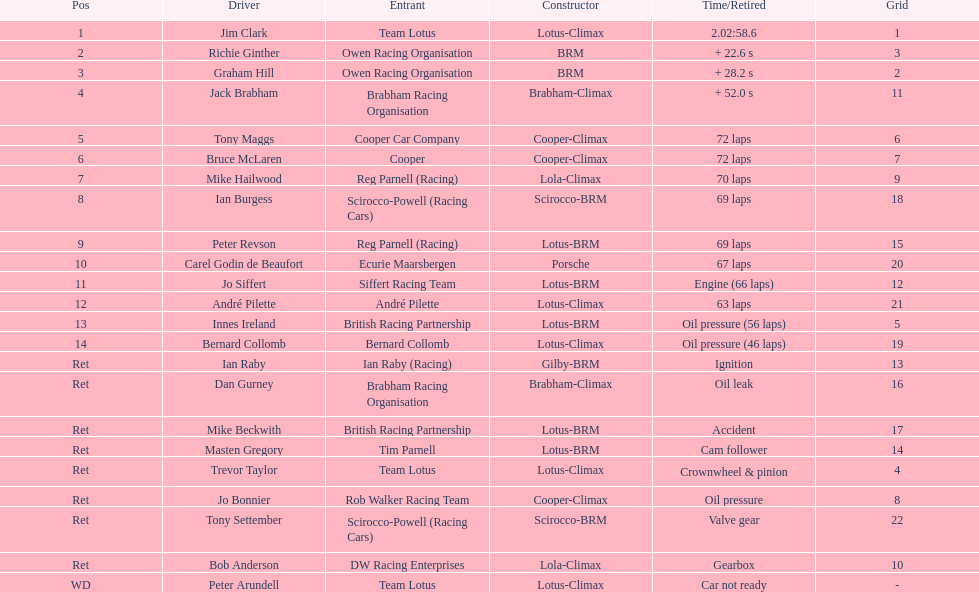Who took the top spot? Jim Clark. 